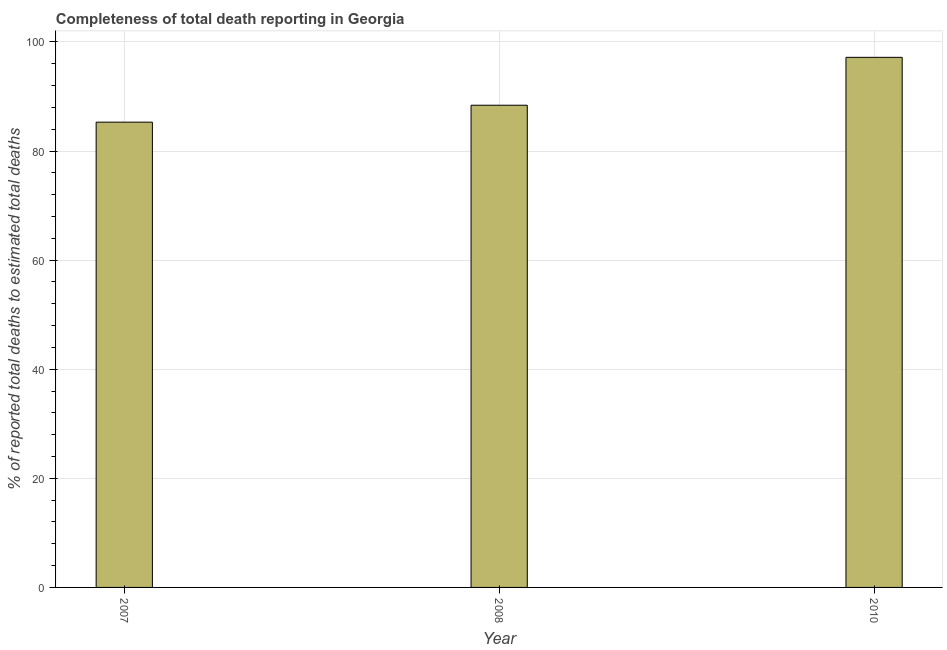Does the graph contain grids?
Ensure brevity in your answer.  Yes. What is the title of the graph?
Your response must be concise. Completeness of total death reporting in Georgia. What is the label or title of the Y-axis?
Offer a very short reply. % of reported total deaths to estimated total deaths. What is the completeness of total death reports in 2007?
Offer a terse response. 85.29. Across all years, what is the maximum completeness of total death reports?
Offer a very short reply. 97.18. Across all years, what is the minimum completeness of total death reports?
Give a very brief answer. 85.29. What is the sum of the completeness of total death reports?
Make the answer very short. 270.86. What is the difference between the completeness of total death reports in 2007 and 2010?
Your response must be concise. -11.88. What is the average completeness of total death reports per year?
Your answer should be compact. 90.29. What is the median completeness of total death reports?
Provide a short and direct response. 88.39. In how many years, is the completeness of total death reports greater than 28 %?
Give a very brief answer. 3. What is the ratio of the completeness of total death reports in 2008 to that in 2010?
Provide a succinct answer. 0.91. Is the completeness of total death reports in 2007 less than that in 2008?
Give a very brief answer. Yes. Is the difference between the completeness of total death reports in 2008 and 2010 greater than the difference between any two years?
Your answer should be very brief. No. What is the difference between the highest and the second highest completeness of total death reports?
Provide a short and direct response. 8.78. What is the difference between the highest and the lowest completeness of total death reports?
Offer a terse response. 11.88. In how many years, is the completeness of total death reports greater than the average completeness of total death reports taken over all years?
Your response must be concise. 1. What is the % of reported total deaths to estimated total deaths of 2007?
Ensure brevity in your answer.  85.29. What is the % of reported total deaths to estimated total deaths in 2008?
Provide a succinct answer. 88.39. What is the % of reported total deaths to estimated total deaths of 2010?
Provide a short and direct response. 97.18. What is the difference between the % of reported total deaths to estimated total deaths in 2007 and 2008?
Keep it short and to the point. -3.1. What is the difference between the % of reported total deaths to estimated total deaths in 2007 and 2010?
Keep it short and to the point. -11.88. What is the difference between the % of reported total deaths to estimated total deaths in 2008 and 2010?
Give a very brief answer. -8.78. What is the ratio of the % of reported total deaths to estimated total deaths in 2007 to that in 2010?
Your answer should be very brief. 0.88. What is the ratio of the % of reported total deaths to estimated total deaths in 2008 to that in 2010?
Your response must be concise. 0.91. 